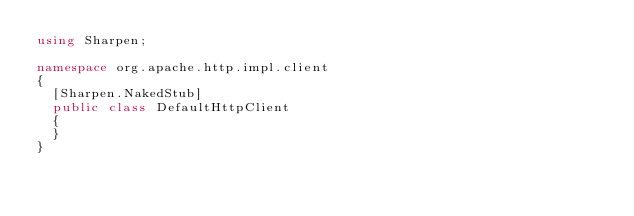<code> <loc_0><loc_0><loc_500><loc_500><_C#_>using Sharpen;

namespace org.apache.http.impl.client
{
	[Sharpen.NakedStub]
	public class DefaultHttpClient
	{
	}
}
</code> 